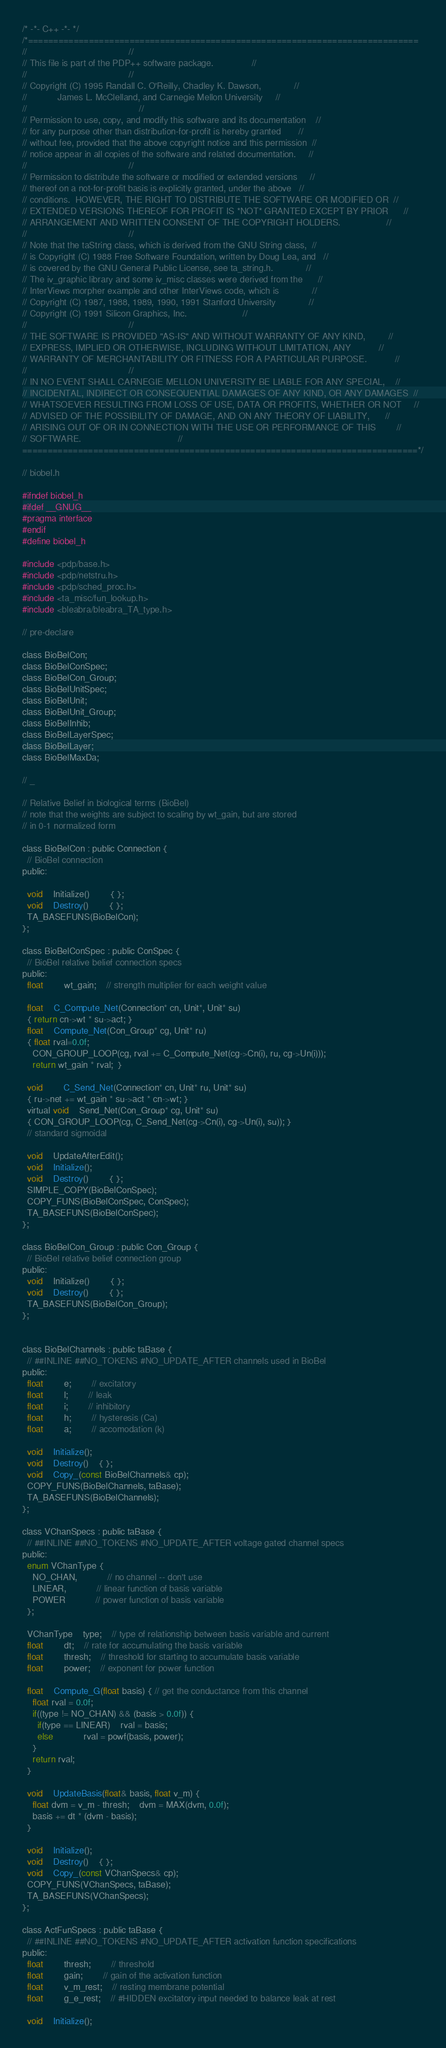Convert code to text. <code><loc_0><loc_0><loc_500><loc_500><_C_>/* -*- C++ -*- */
/*=============================================================================
//									      //
// This file is part of the PDP++ software package.			      //
//									      //
// Copyright (C) 1995 Randall C. O'Reilly, Chadley K. Dawson, 		      //
//		      James L. McClelland, and Carnegie Mellon University     //
//     									      //
// Permission to use, copy, and modify this software and its documentation    //
// for any purpose other than distribution-for-profit is hereby granted	      //
// without fee, provided that the above copyright notice and this permission  //
// notice appear in all copies of the software and related documentation.     //
//									      //
// Permission to distribute the software or modified or extended versions     //
// thereof on a not-for-profit basis is explicitly granted, under the above   //
// conditions. 	HOWEVER, THE RIGHT TO DISTRIBUTE THE SOFTWARE OR MODIFIED OR  //
// EXTENDED VERSIONS THEREOF FOR PROFIT IS *NOT* GRANTED EXCEPT BY PRIOR      //
// ARRANGEMENT AND WRITTEN CONSENT OF THE COPYRIGHT HOLDERS.                  //
// 									      //
// Note that the taString class, which is derived from the GNU String class,  //
// is Copyright (C) 1988 Free Software Foundation, written by Doug Lea, and   //
// is covered by the GNU General Public License, see ta_string.h.             //
// The iv_graphic library and some iv_misc classes were derived from the      //
// InterViews morpher example and other InterViews code, which is             //
// Copyright (C) 1987, 1988, 1989, 1990, 1991 Stanford University             //
// Copyright (C) 1991 Silicon Graphics, Inc.				      //
//									      //
// THE SOFTWARE IS PROVIDED "AS-IS" AND WITHOUT WARRANTY OF ANY KIND,         //
// EXPRESS, IMPLIED OR OTHERWISE, INCLUDING WITHOUT LIMITATION, ANY 	      //
// WARRANTY OF MERCHANTABILITY OR FITNESS FOR A PARTICULAR PURPOSE.  	      //
// 									      //
// IN NO EVENT SHALL CARNEGIE MELLON UNIVERSITY BE LIABLE FOR ANY SPECIAL,    //
// INCIDENTAL, INDIRECT OR CONSEQUENTIAL DAMAGES OF ANY KIND, OR ANY DAMAGES  //
// WHATSOEVER RESULTING FROM LOSS OF USE, DATA OR PROFITS, WHETHER OR NOT     //
// ADVISED OF THE POSSIBILITY OF DAMAGE, AND ON ANY THEORY OF LIABILITY,      //
// ARISING OUT OF OR IN CONNECTION WITH THE USE OR PERFORMANCE OF THIS        //
// SOFTWARE. 								      //
==============================================================================*/

// biobel.h 

#ifndef biobel_h
#ifdef __GNUG__
#pragma interface
#endif
#define biobel_h

#include <pdp/base.h>
#include <pdp/netstru.h>
#include <pdp/sched_proc.h>
#include <ta_misc/fun_lookup.h>
#include <bleabra/bleabra_TA_type.h>

// pre-declare

class BioBelCon;
class BioBelConSpec;
class BioBelCon_Group;
class BioBelUnitSpec;
class BioBelUnit;
class BioBelUnit_Group;
class BioBelInhib;
class BioBelLayerSpec;
class BioBelLayer;
class BioBelMaxDa;

// _

// Relative Belief in biological terms (BioBel) 
// note that the weights are subject to scaling by wt_gain, but are stored
// in 0-1 normalized form

class BioBelCon : public Connection {
  // BioBel connection
public:

  void 	Initialize()		{ };
  void	Destroy()		{ };
  TA_BASEFUNS(BioBelCon);
};

class BioBelConSpec : public ConSpec {
  // BioBel relative belief connection specs
public:
  float		wt_gain;	// strength multiplier for each weight value

  float 	C_Compute_Net(Connection* cn, Unit*, Unit* su)
  { return cn->wt * su->act; }
  float 	Compute_Net(Con_Group* cg, Unit* ru)
  { float rval=0.0f;
    CON_GROUP_LOOP(cg, rval += C_Compute_Net(cg->Cn(i), ru, cg->Un(i)));
    return wt_gain * rval;  }

  void 		C_Send_Net(Connection* cn, Unit* ru, Unit* su)
  { ru->net += wt_gain * su->act * cn->wt; }
  virtual void 	Send_Net(Con_Group* cg, Unit* su)
  { CON_GROUP_LOOP(cg, C_Send_Net(cg->Cn(i), cg->Un(i), su)); }
  // standard sigmoidal

  void	UpdateAfterEdit();
  void 	Initialize();
  void	Destroy()		{ };
  SIMPLE_COPY(BioBelConSpec);
  COPY_FUNS(BioBelConSpec, ConSpec);
  TA_BASEFUNS(BioBelConSpec);
};

class BioBelCon_Group : public Con_Group {
  // BioBel relative belief connection group
public:
  void 	Initialize()		{ };
  void	Destroy()		{ };
  TA_BASEFUNS(BioBelCon_Group);
};


class BioBelChannels : public taBase {
  // ##INLINE ##NO_TOKENS #NO_UPDATE_AFTER channels used in BioBel
public:
  float		e;		// excitatory
  float		l;		// leak
  float		i;		// inhibitory
  float		h;		// hysteresis (Ca)
  float		a;		// accomodation (k)

  void	Initialize();
  void	Destroy()	{ };
  void 	Copy_(const BioBelChannels& cp);
  COPY_FUNS(BioBelChannels, taBase);
  TA_BASEFUNS(BioBelChannels);
};

class VChanSpecs : public taBase {
  // ##INLINE ##NO_TOKENS #NO_UPDATE_AFTER voltage gated channel specs
public:
  enum VChanType {
    NO_CHAN,			// no channel -- don't use
    LINEAR,			// linear function of basis variable
    POWER			// power function of basis variable
  };
  
  VChanType	type;	// type of relationship between basis variable and current
  float		dt;	// rate for accumulating the basis variable
  float		thresh;	// threshold for starting to accumulate basis variable
  float		power;	// exponent for power function

  float	Compute_G(float basis) { // get the conductance from this channel
    float rval = 0.0f;
    if((type != NO_CHAN) && (basis > 0.0f)) {
      if(type == LINEAR)	rval = basis;
      else 			rval = powf(basis, power);
    }
    return rval;
  }

  void	UpdateBasis(float& basis, float v_m) {
    float dvm = v_m - thresh; 	dvm = MAX(dvm, 0.0f);
    basis += dt * (dvm - basis);
  }

  void	Initialize();
  void	Destroy()	{ };
  void 	Copy_(const VChanSpecs& cp);
  COPY_FUNS(VChanSpecs, taBase);
  TA_BASEFUNS(VChanSpecs);
};

class ActFunSpecs : public taBase {
  // ##INLINE ##NO_TOKENS #NO_UPDATE_AFTER activation function specifications
public:
  float		thresh;		// threshold
  float		gain;		// gain of the activation function
  float		v_m_rest;	// resting membrane potential
  float		g_e_rest;	// #HIDDEN excitatory input needed to balance leak at rest

  void	Initialize();</code> 